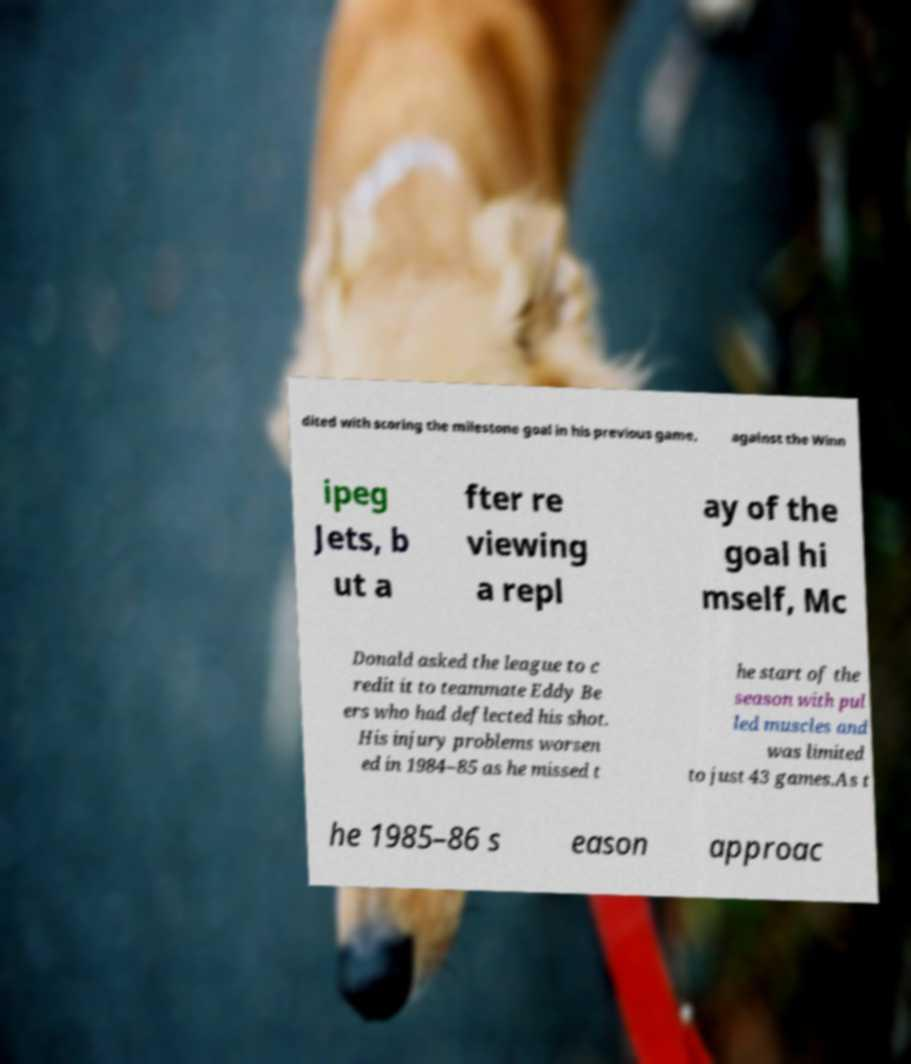What messages or text are displayed in this image? I need them in a readable, typed format. dited with scoring the milestone goal in his previous game, against the Winn ipeg Jets, b ut a fter re viewing a repl ay of the goal hi mself, Mc Donald asked the league to c redit it to teammate Eddy Be ers who had deflected his shot. His injury problems worsen ed in 1984–85 as he missed t he start of the season with pul led muscles and was limited to just 43 games.As t he 1985–86 s eason approac 